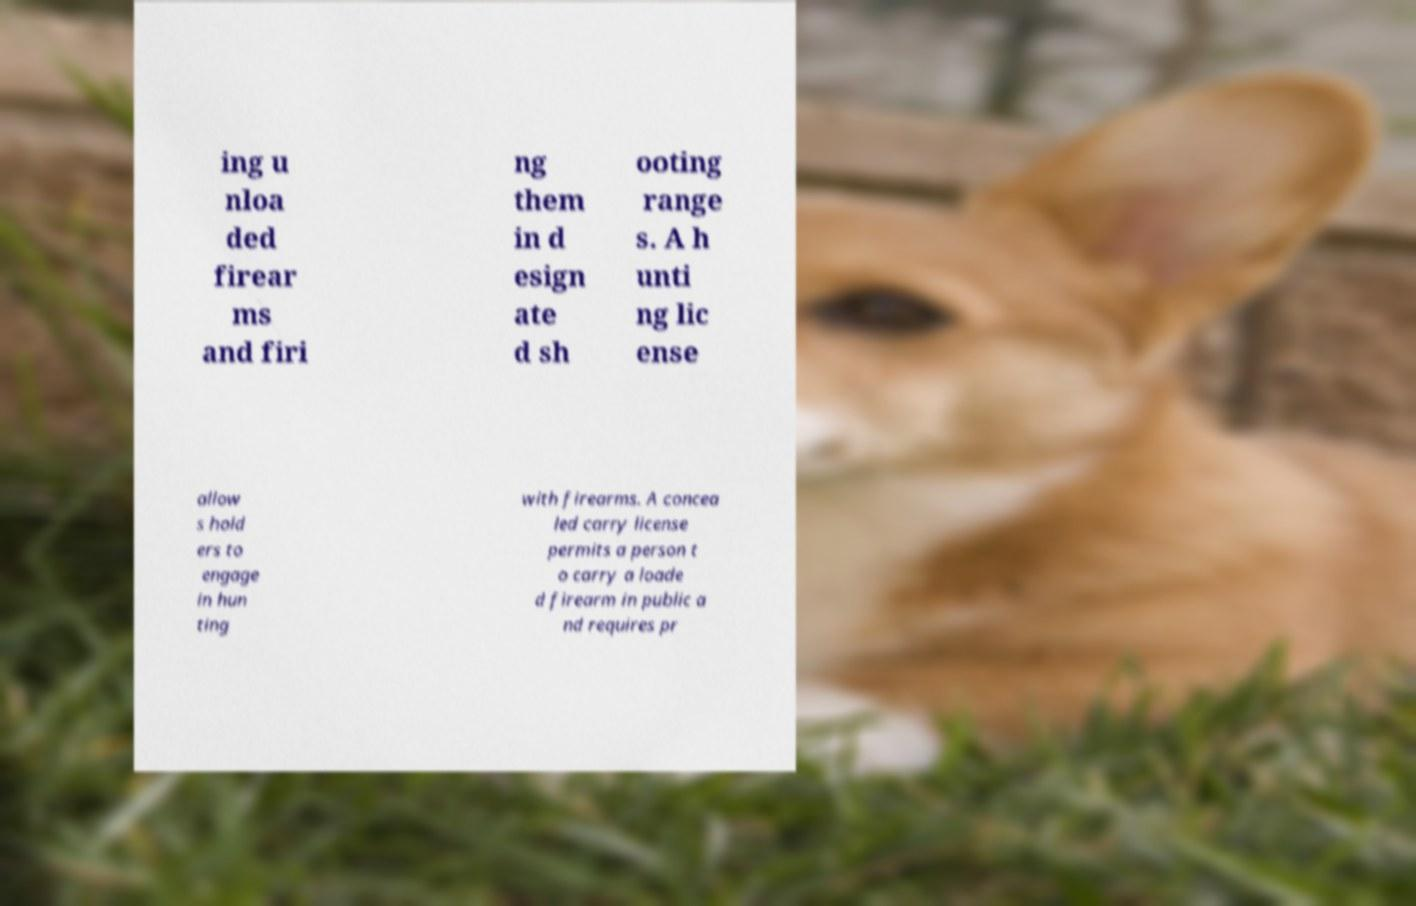There's text embedded in this image that I need extracted. Can you transcribe it verbatim? ing u nloa ded firear ms and firi ng them in d esign ate d sh ooting range s. A h unti ng lic ense allow s hold ers to engage in hun ting with firearms. A concea led carry license permits a person t o carry a loade d firearm in public a nd requires pr 